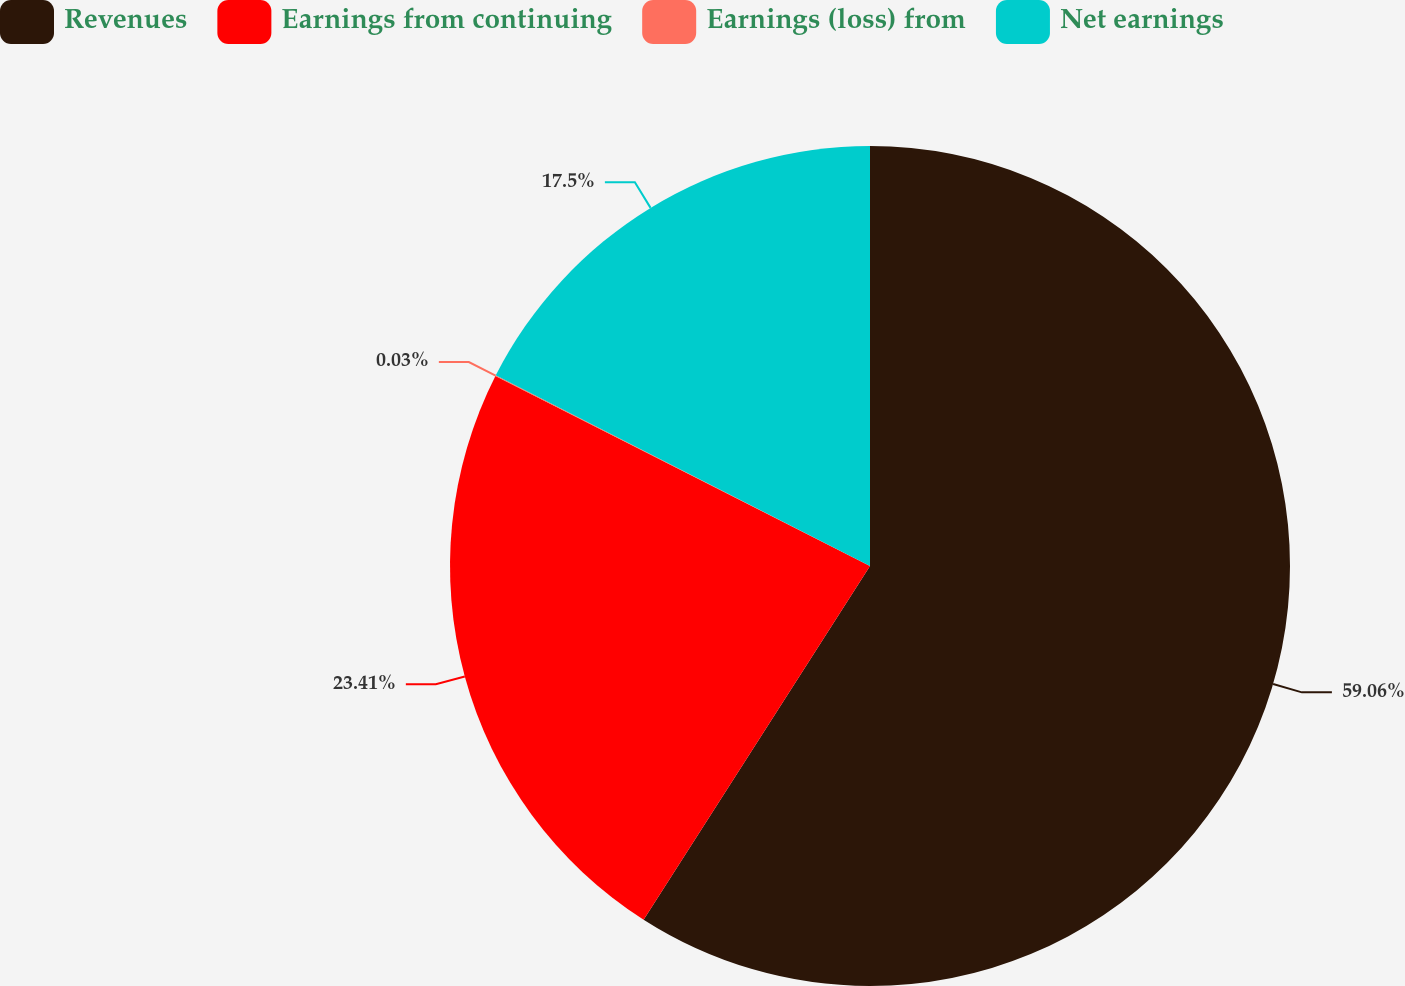Convert chart. <chart><loc_0><loc_0><loc_500><loc_500><pie_chart><fcel>Revenues<fcel>Earnings from continuing<fcel>Earnings (loss) from<fcel>Net earnings<nl><fcel>59.06%<fcel>23.41%<fcel>0.03%<fcel>17.5%<nl></chart> 